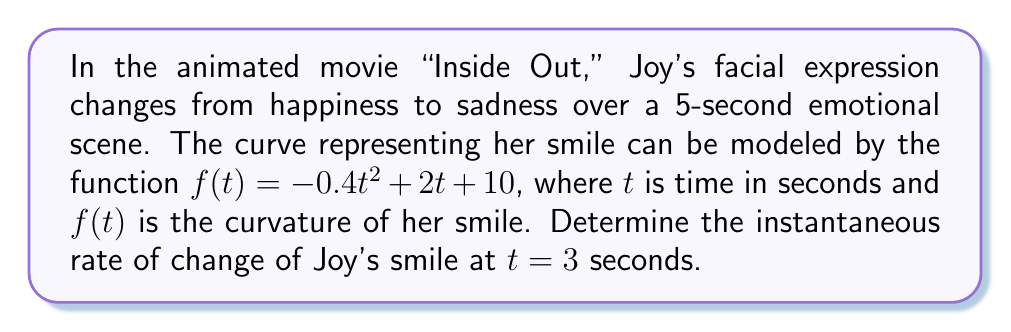Provide a solution to this math problem. To find the instantaneous rate of change at $t = 3$ seconds, we need to calculate the derivative of the function $f(t)$ and evaluate it at $t = 3$.

Step 1: Find the derivative of $f(t)$.
$f(t) = -0.4t^2 + 2t + 10$
$f'(t) = -0.8t + 2$ (using the power rule and constant rule of differentiation)

Step 2: Evaluate $f'(t)$ at $t = 3$.
$f'(3) = -0.8(3) + 2$
$f'(3) = -2.4 + 2$
$f'(3) = -0.4$

The negative value indicates that Joy's smile is decreasing (turning into a frown) at this moment.
Answer: $-0.4$ units/second 